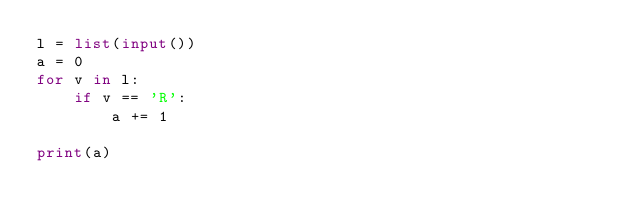<code> <loc_0><loc_0><loc_500><loc_500><_Python_>l = list(input())
a = 0
for v in l:
    if v == 'R':
        a += 1
        
print(a)</code> 